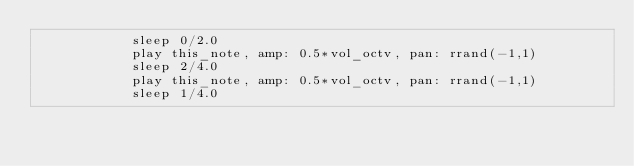Convert code to text. <code><loc_0><loc_0><loc_500><loc_500><_Ruby_>            sleep 0/2.0
            play this_note, amp: 0.5*vol_octv, pan: rrand(-1,1)
            sleep 2/4.0
            play this_note, amp: 0.5*vol_octv, pan: rrand(-1,1)
            sleep 1/4.0</code> 